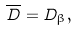<formula> <loc_0><loc_0><loc_500><loc_500>\overline { D } = D _ { \beta } ,</formula> 